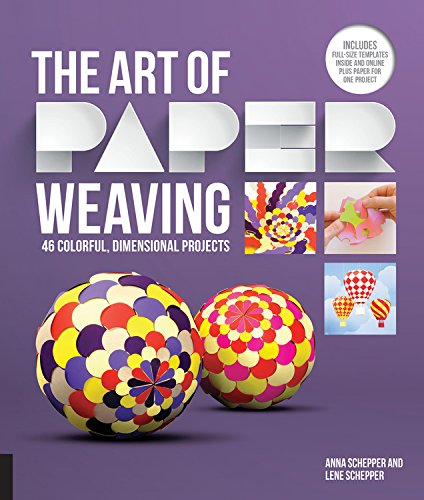What type of book is this? This book falls under the 'Crafts, Hobbies & Home' category, specifically focusing on paper weaving which is a detailed crafting technique to create dimensional and colorful art pieces. 